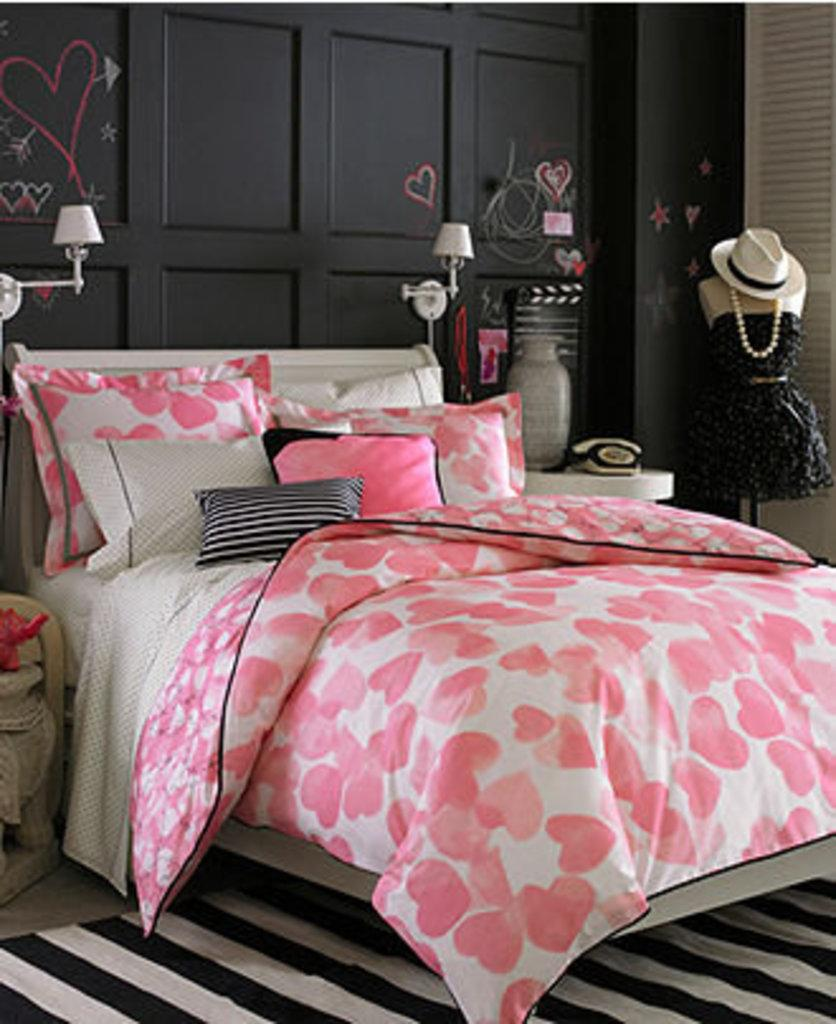What piece of furniture is present in the image? There is a bed in the image. What is covering the bed? There is a blanket on the bed. What is used for head support on the bed? There is a pillow on the bed. What objects are on the table in the image? There is a telephone and a vase on the table. What type of cheese is present on the bed in the image? There is no cheese present on the bed or in the image. 